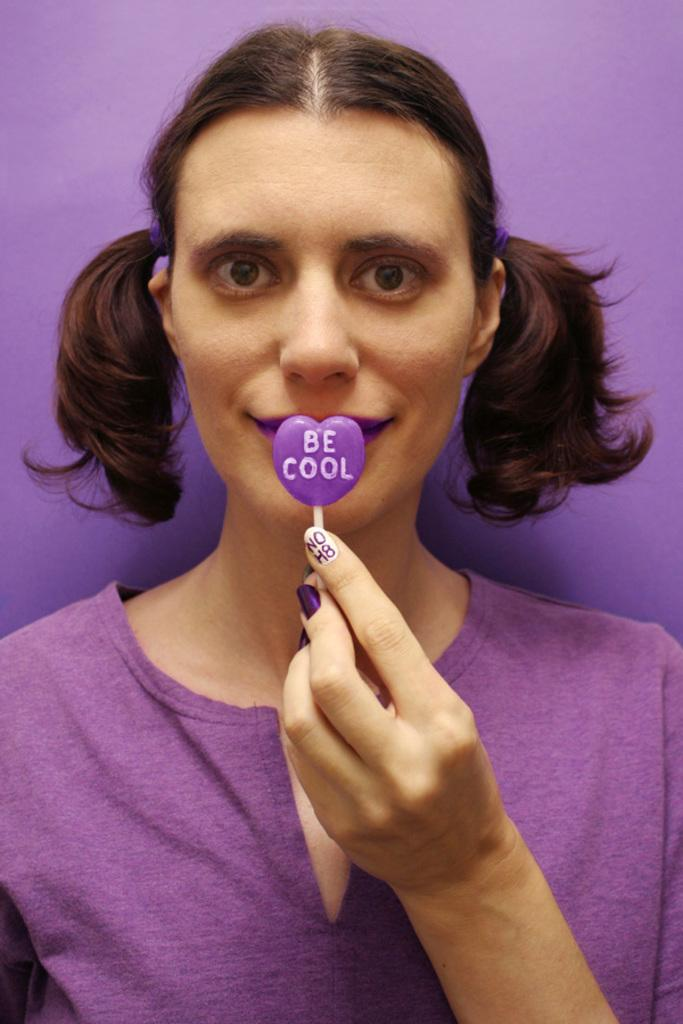Who is the main subject in the image? There is a girl in the image. What is the girl wearing? The girl is wearing a violet-colored dress. What is the girl holding in the image? The girl is holding a violet-colored lollipop. What type of punishment is the girl receiving in the image? There is no indication of punishment in the image; the girl is simply holding a lollipop. What kind of toy is the girl playing with in the image? There is no toy visible in the image; the girl is holding a lollipop. 